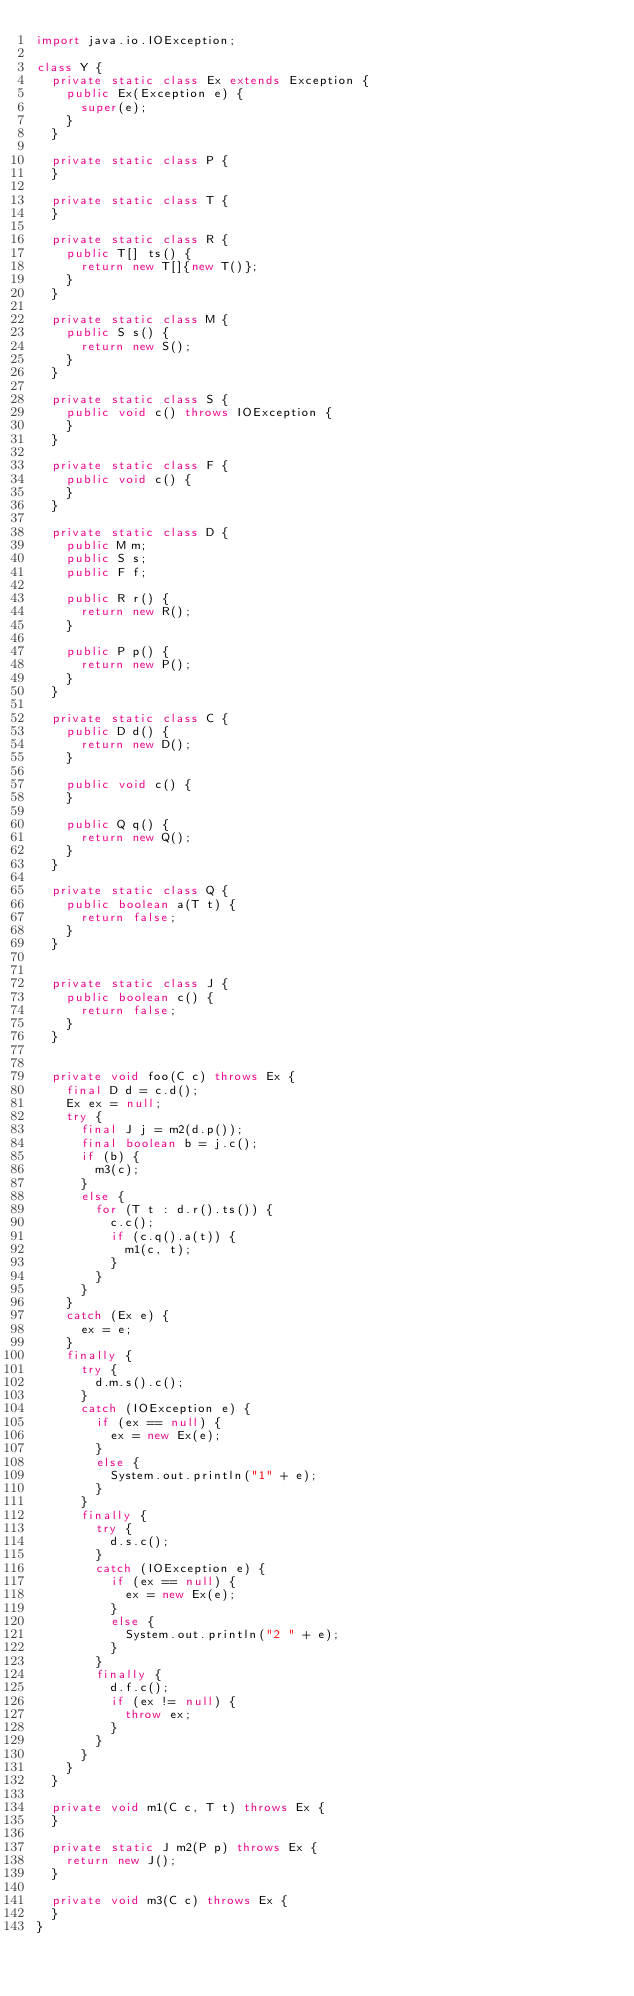<code> <loc_0><loc_0><loc_500><loc_500><_Java_>import java.io.IOException;

class Y {
  private static class Ex extends Exception {
    public Ex(Exception e) {
      super(e);
    }
  }

  private static class P {
  }

  private static class T {
  }

  private static class R {
    public T[] ts() {
      return new T[]{new T()};
    }
  }

  private static class M {
    public S s() {
      return new S();
    }
  }

  private static class S {
    public void c() throws IOException {
    }
  }

  private static class F {
    public void c() {
    }
  }

  private static class D {
    public M m;
    public S s;
    public F f;

    public R r() {
      return new R();
    }

    public P p() {
      return new P();
    }
  }

  private static class C {
    public D d() {
      return new D();
    }

    public void c() {
    }

    public Q q() {
      return new Q();
    }
  }

  private static class Q {
    public boolean a(T t) {
      return false;
    }
  }


  private static class J {
    public boolean c() {
      return false;
    }
  }


  private void foo(C c) throws Ex {
    final D d = c.d();
    Ex ex = null;
    try {
      final J j = m2(d.p());
      final boolean b = j.c();
      if (b) {
        m3(c);
      }
      else {
        for (T t : d.r().ts()) {
          c.c();
          if (c.q().a(t)) {
            m1(c, t);
          }
        }
      }
    }
    catch (Ex e) {
      ex = e;
    }
    finally {
      try {
        d.m.s().c();
      }
      catch (IOException e) {
        if (ex == null) {
          ex = new Ex(e);
        }
        else {
          System.out.println("1" + e);
        }
      }
      finally {
        try {
          d.s.c();
        }
        catch (IOException e) {
          if (ex == null) {
            ex = new Ex(e);
          }
          else {
            System.out.println("2 " + e);
          }
        }
        finally {
          d.f.c();
          if (ex != null) {
            throw ex;
          }
        }
      }
    }
  }

  private void m1(C c, T t) throws Ex {
  }

  private static J m2(P p) throws Ex {
    return new J();
  }

  private void m3(C c) throws Ex {
  }
}
</code> 